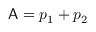<formula> <loc_0><loc_0><loc_500><loc_500>A = p _ { 1 } + p _ { 2 }</formula> 